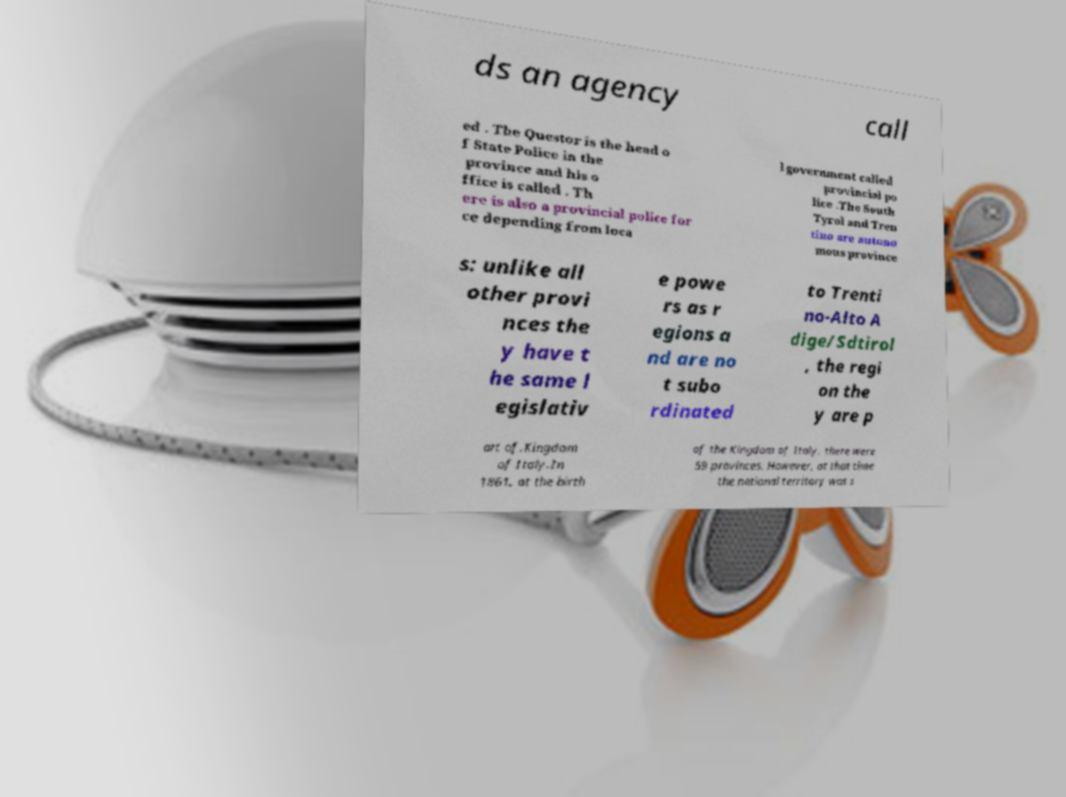Can you read and provide the text displayed in the image?This photo seems to have some interesting text. Can you extract and type it out for me? ds an agency call ed . The Questor is the head o f State Police in the province and his o ffice is called . Th ere is also a provincial police for ce depending from loca l government called provincial po lice .The South Tyrol and Tren tino are autono mous province s: unlike all other provi nces the y have t he same l egislativ e powe rs as r egions a nd are no t subo rdinated to Trenti no-Alto A dige/Sdtirol , the regi on the y are p art of.Kingdom of Italy.In 1861, at the birth of the Kingdom of Italy, there were 59 provinces. However, at that time the national territory was s 